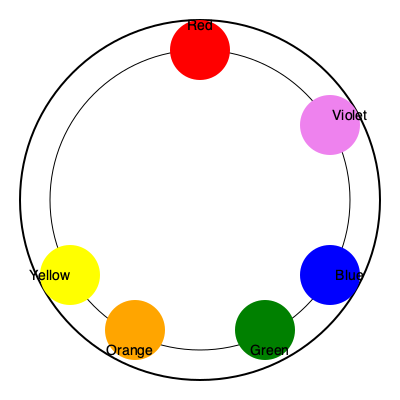As a painter establishing your studio, understanding color theory is crucial. In the given color wheel, which color is complementary to orange, and how might this knowledge influence your artistic decisions? To answer this question, let's follow these steps:

1. Understand complementary colors:
   - Complementary colors are pairs of colors that are opposite each other on the color wheel.
   - They create maximum contrast and vibrancy when used together.

2. Locate orange on the color wheel:
   - Orange is a secondary color, positioned between red and yellow.

3. Identify the complementary color:
   - The color directly opposite orange on the wheel is blue.

4. Understand the significance for artistic decisions:
   - Complementary colors can be used to create striking contrasts in paintings.
   - When placed side by side, complementary colors make each other appear more vibrant.
   - Using blue alongside orange can create a dynamic and visually appealing composition.
   - This knowledge can be applied in various ways:
     a. Creating focal points in a painting
     b. Balancing warm and cool tones
     c. Enhancing the perceived intensity of colors

5. Application in a studio setting:
   - Understanding color theory helps in mixing paints effectively.
   - It aids in creating harmonious or contrasting color schemes in artwork.
   - This knowledge can be used to evoke specific emotions or atmospheres in paintings.

By understanding and applying the principle of complementary colors, you can create more impactful and visually striking artwork in your new studio.
Answer: Blue; enhances contrast and vibrancy in compositions 